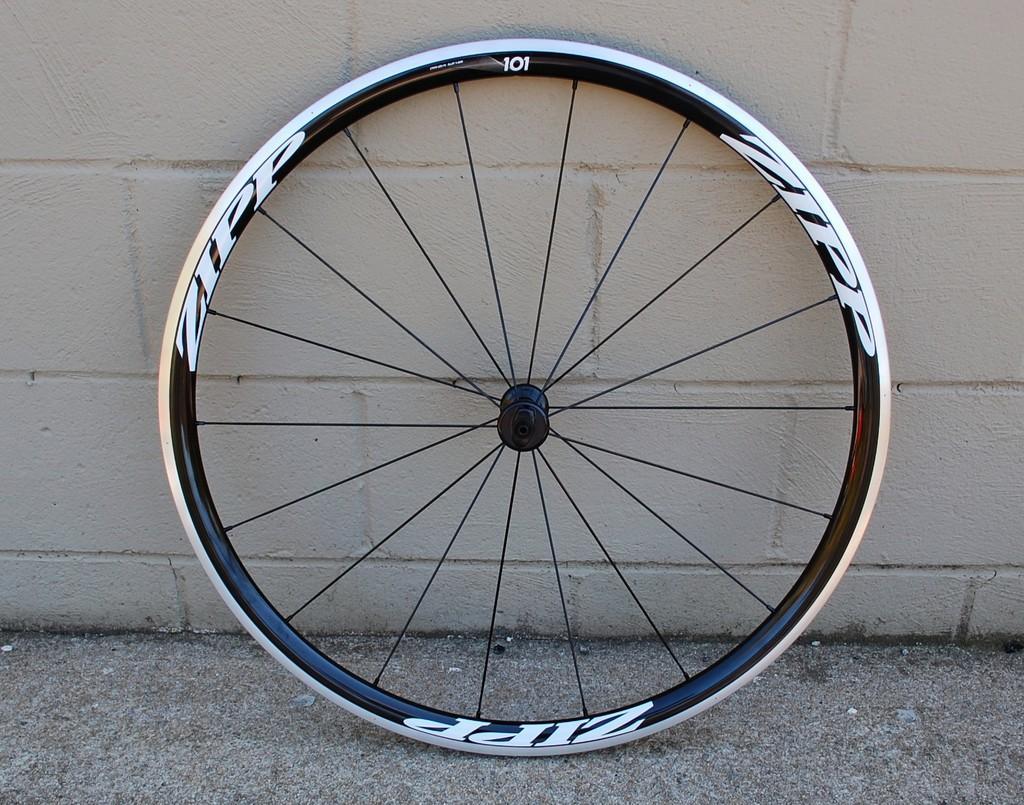Describe this image in one or two sentences. This picture is clicked outside. In the center we can see a wheel placed on the ground. In the background there is a wall. 